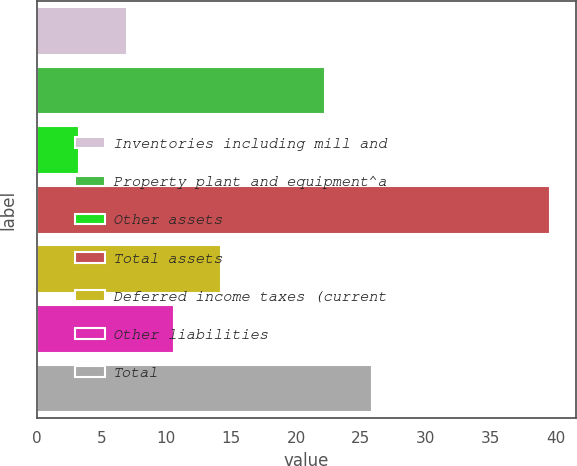Convert chart. <chart><loc_0><loc_0><loc_500><loc_500><bar_chart><fcel>Inventories including mill and<fcel>Property plant and equipment^a<fcel>Other assets<fcel>Total assets<fcel>Deferred income taxes (current<fcel>Other liabilities<fcel>Total<nl><fcel>6.93<fcel>22.2<fcel>3.3<fcel>39.6<fcel>14.19<fcel>10.56<fcel>25.83<nl></chart> 